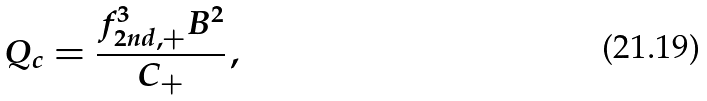Convert formula to latex. <formula><loc_0><loc_0><loc_500><loc_500>Q _ { c } = \frac { f _ { 2 n d , + } ^ { 3 } B ^ { 2 } } { C _ { + } } \, ,</formula> 